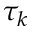<formula> <loc_0><loc_0><loc_500><loc_500>\tau _ { k }</formula> 